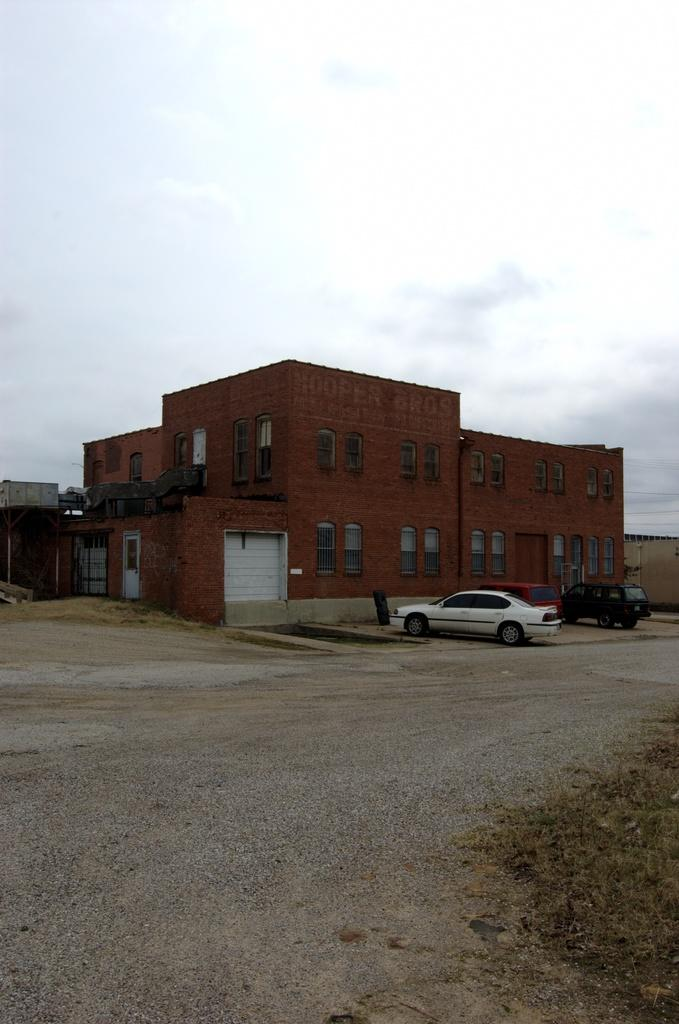What is in the foreground of the image? There is a road and grass in the foreground of the image. What can be seen in the middle of the image? There are cars and a building in the middle of the image. What is visible at the top of the image? The sky is visible at the top of the image. How many feet are visible in the image? There are no feet visible in the image. What type of system is being managed in the image? There is no system or manager present in the image. 